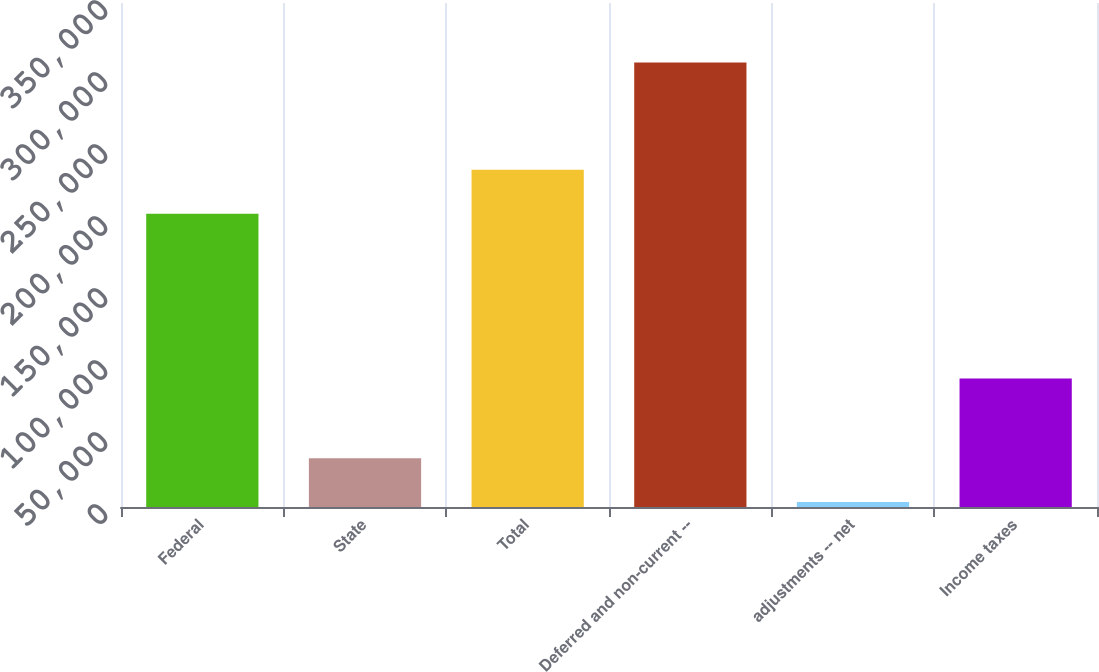Convert chart to OTSL. <chart><loc_0><loc_0><loc_500><loc_500><bar_chart><fcel>Federal<fcel>State<fcel>Total<fcel>Deferred and non-current --<fcel>adjustments -- net<fcel>Income taxes<nl><fcel>203651<fcel>33932.2<fcel>234176<fcel>308659<fcel>3407<fcel>89185<nl></chart> 